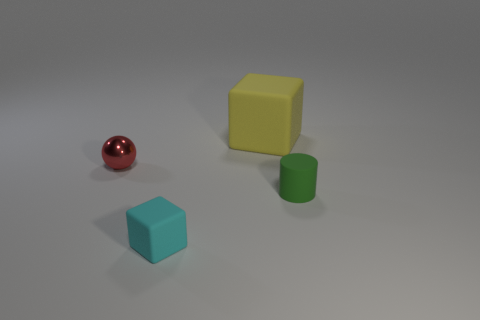Add 1 small brown shiny cylinders. How many objects exist? 5 Subtract all cylinders. How many objects are left? 3 Add 1 matte cylinders. How many matte cylinders are left? 2 Add 3 blocks. How many blocks exist? 5 Subtract 0 brown cubes. How many objects are left? 4 Subtract all green cubes. Subtract all blue spheres. How many cubes are left? 2 Subtract all small blue matte balls. Subtract all large yellow cubes. How many objects are left? 3 